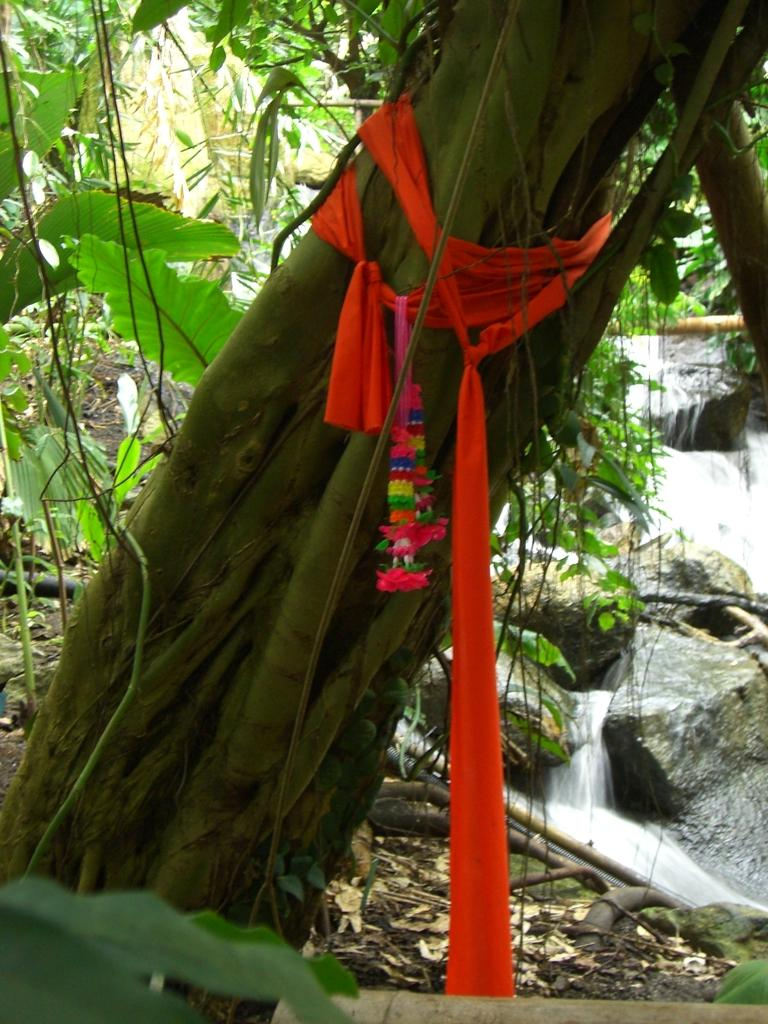What is unusual about the tree trunk in the image? The tree trunk is tied with clothes. What can be seen in the background of the image? There are plants, rocks, a waterfall, a pipe, and dry leaves present in the background of the image. How does the tree trunk push the waterfall in the image? The tree trunk does not push the waterfall in the image; it is tied with clothes and not interacting with the waterfall. 